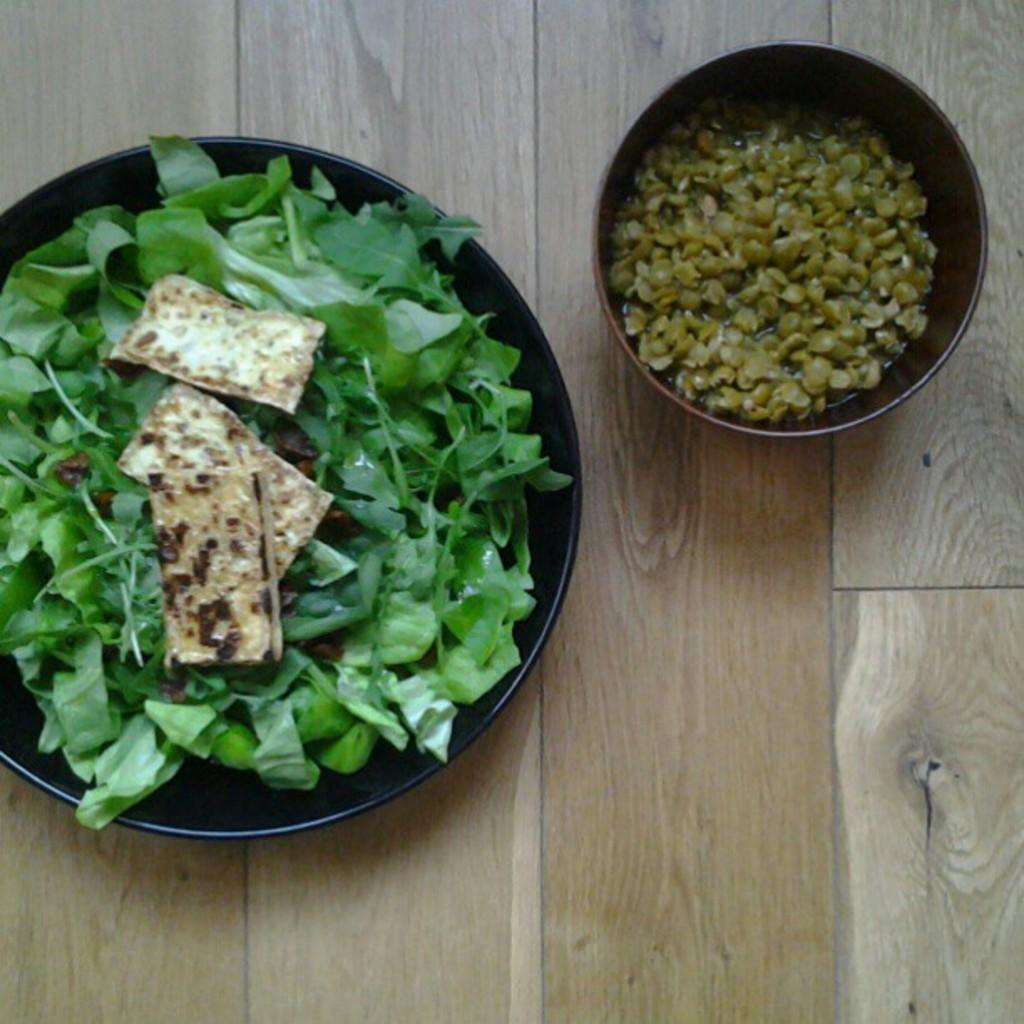What type of food can be seen in the plate in the image? There is food in the plate in the image. What type of food can be seen in the bowl in the image? There is food in the bowl in the image. What colors are present in the food? The food has green, white, and brown colors. What is the color of the surface on which the plate and bowl are placed? The plate and bowl are on a brown surface. What emotion is the food expressing in the image? Food does not have emotions, so it cannot express anger or any other emotion in the image. 